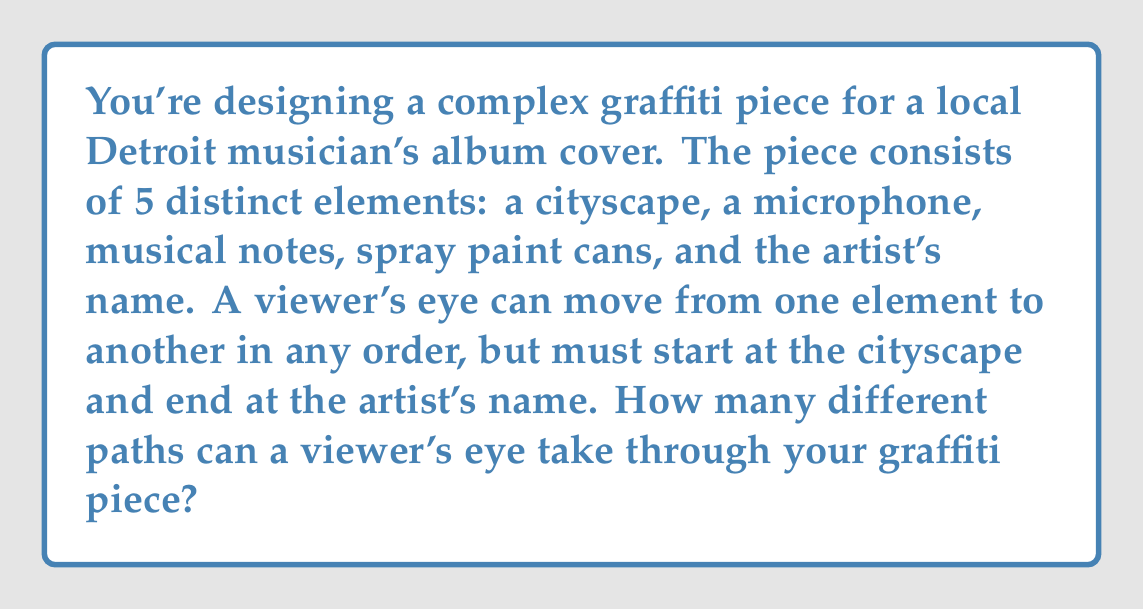Give your solution to this math problem. Let's approach this step-by-step:

1) We start with the cityscape and end with the artist's name. This means we need to arrange the other 3 elements (microphone, musical notes, and spray paint cans) in between.

2) This is a permutation problem. We're arranging 3 elements in all possible orders.

3) The number of permutations of n distinct objects is given by n!

4) In this case, n = 3

5) Therefore, the number of different paths is:

   $$3! = 3 \times 2 \times 1 = 6$$

6) We can list out all these paths to verify:
   - Cityscape → Microphone → Musical Notes → Spray Paint Cans → Artist's Name
   - Cityscape → Microphone → Spray Paint Cans → Musical Notes → Artist's Name
   - Cityscape → Musical Notes → Microphone → Spray Paint Cans → Artist's Name
   - Cityscape → Musical Notes → Spray Paint Cans → Microphone → Artist's Name
   - Cityscape → Spray Paint Cans → Microphone → Musical Notes → Artist's Name
   - Cityscape → Spray Paint Cans → Musical Notes → Microphone → Artist's Name

Thus, there are 6 different paths a viewer's eye can take through your graffiti piece.
Answer: 6 